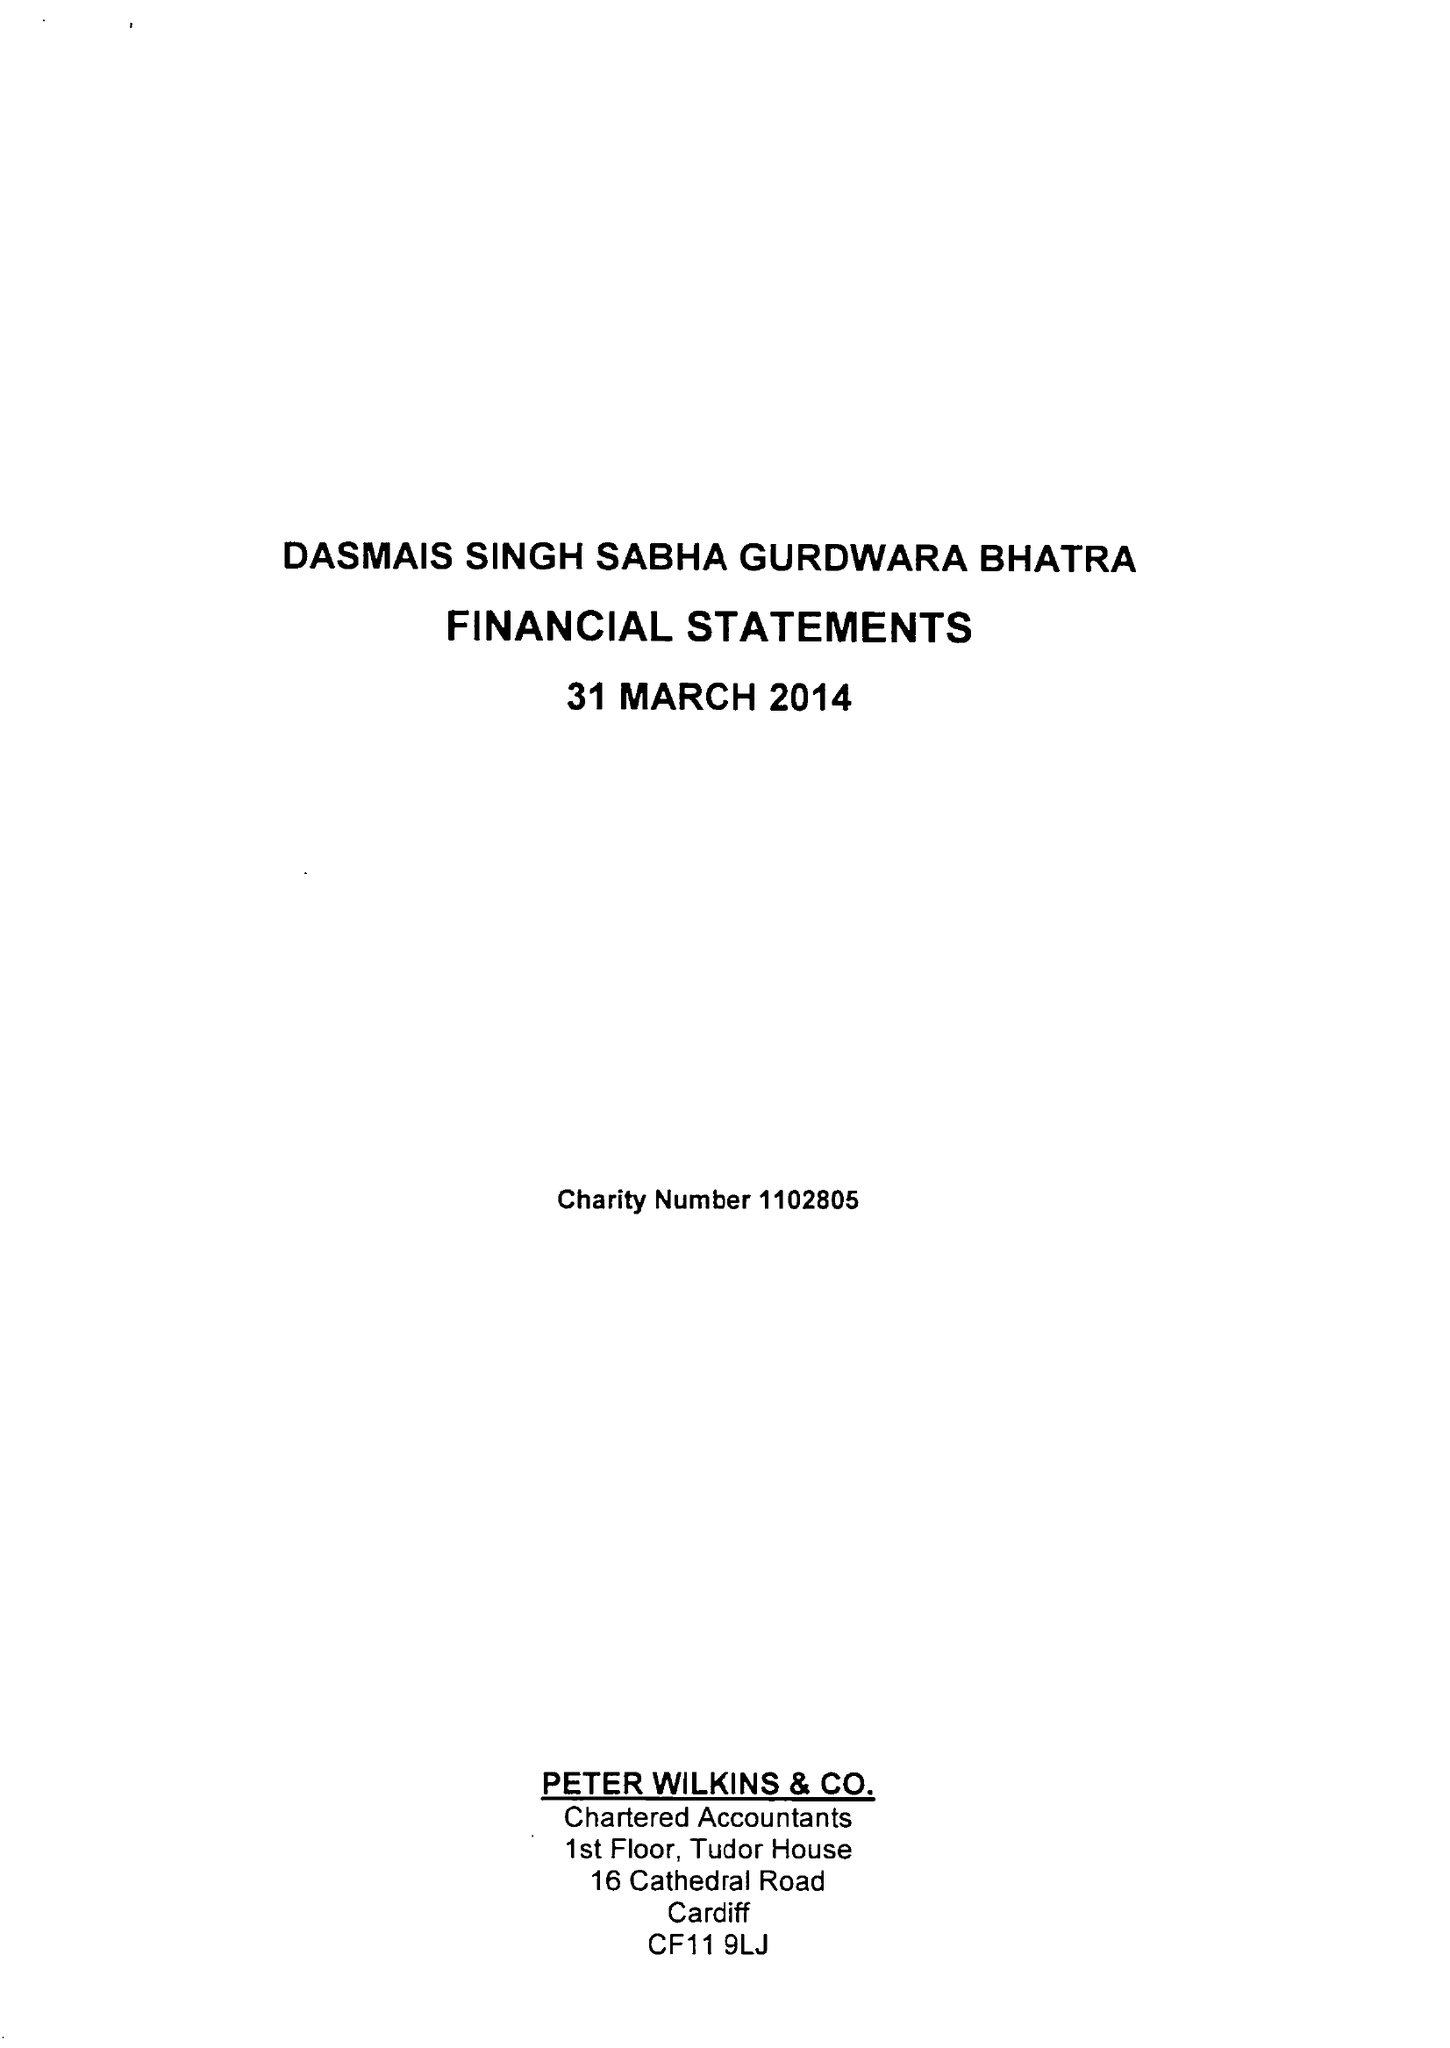What is the value for the charity_name?
Answer the question using a single word or phrase. Dasmais Singh Saba Gurdwara Bhatra 